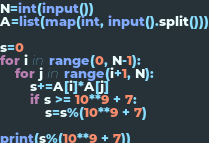<code> <loc_0><loc_0><loc_500><loc_500><_Python_>N=int(input())
A=list(map(int, input().split()))

s=0
for i in range(0, N-1):
    for j in range(i+1, N):
        s+=A[i]*A[j]
        if s >= 10**9 + 7:
            s=s%(10**9 + 7)

print(s%(10**9 + 7))


</code> 